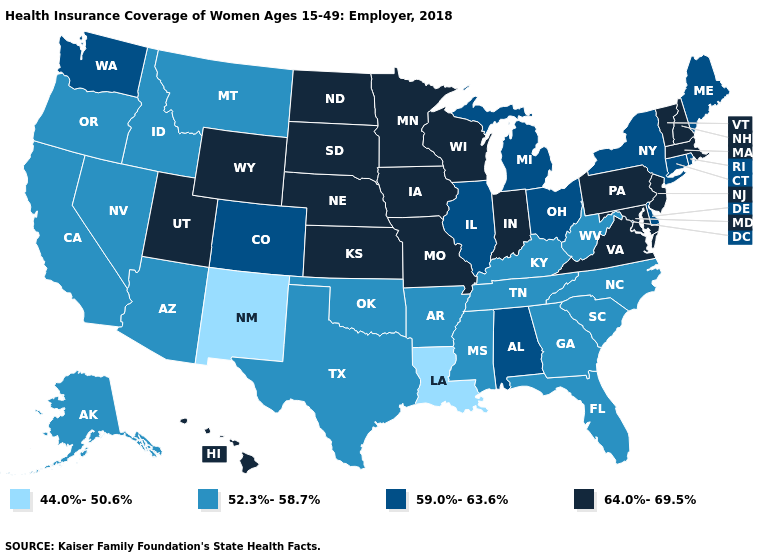Does the first symbol in the legend represent the smallest category?
Give a very brief answer. Yes. What is the value of Nevada?
Concise answer only. 52.3%-58.7%. Name the states that have a value in the range 64.0%-69.5%?
Write a very short answer. Hawaii, Indiana, Iowa, Kansas, Maryland, Massachusetts, Minnesota, Missouri, Nebraska, New Hampshire, New Jersey, North Dakota, Pennsylvania, South Dakota, Utah, Vermont, Virginia, Wisconsin, Wyoming. Among the states that border Delaware , which have the highest value?
Be succinct. Maryland, New Jersey, Pennsylvania. Name the states that have a value in the range 52.3%-58.7%?
Short answer required. Alaska, Arizona, Arkansas, California, Florida, Georgia, Idaho, Kentucky, Mississippi, Montana, Nevada, North Carolina, Oklahoma, Oregon, South Carolina, Tennessee, Texas, West Virginia. Does Louisiana have the highest value in the South?
Keep it brief. No. Which states have the lowest value in the USA?
Be succinct. Louisiana, New Mexico. Does Illinois have the highest value in the MidWest?
Quick response, please. No. Does the first symbol in the legend represent the smallest category?
Answer briefly. Yes. Which states have the lowest value in the Northeast?
Be succinct. Connecticut, Maine, New York, Rhode Island. What is the value of Missouri?
Write a very short answer. 64.0%-69.5%. What is the value of Rhode Island?
Keep it brief. 59.0%-63.6%. Does Kansas have a higher value than California?
Quick response, please. Yes. Among the states that border Utah , does New Mexico have the lowest value?
Answer briefly. Yes. Name the states that have a value in the range 64.0%-69.5%?
Quick response, please. Hawaii, Indiana, Iowa, Kansas, Maryland, Massachusetts, Minnesota, Missouri, Nebraska, New Hampshire, New Jersey, North Dakota, Pennsylvania, South Dakota, Utah, Vermont, Virginia, Wisconsin, Wyoming. 